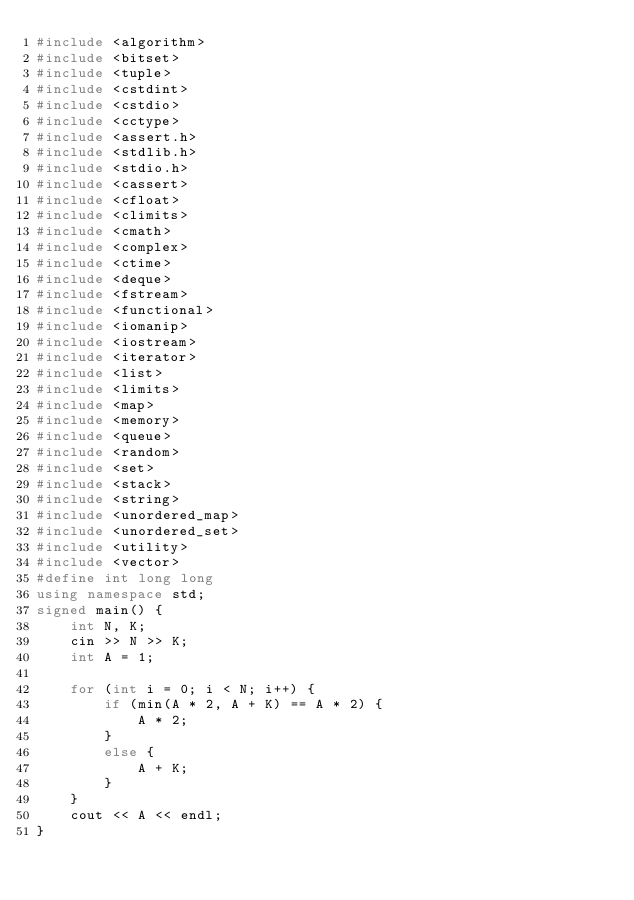<code> <loc_0><loc_0><loc_500><loc_500><_C++_>#include <algorithm>
#include <bitset>
#include <tuple>
#include <cstdint>
#include <cstdio>
#include <cctype>
#include <assert.h>
#include <stdlib.h>
#include <stdio.h>
#include <cassert>
#include <cfloat>
#include <climits>
#include <cmath>
#include <complex>
#include <ctime>
#include <deque>
#include <fstream>
#include <functional>
#include <iomanip>
#include <iostream>
#include <iterator>
#include <list>
#include <limits>
#include <map>
#include <memory>
#include <queue>
#include <random>
#include <set>
#include <stack>
#include <string>
#include <unordered_map>
#include <unordered_set>
#include <utility>
#include <vector>
#define int long long
using namespace std;
signed main() {
    int N, K;
    cin >> N >> K;
    int A = 1;

    for (int i = 0; i < N; i++) {
        if (min(A * 2, A + K) == A * 2) {
            A * 2;
        }
        else {
            A + K;
        }
    }
    cout << A << endl;
}</code> 